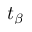Convert formula to latex. <formula><loc_0><loc_0><loc_500><loc_500>t _ { \beta }</formula> 